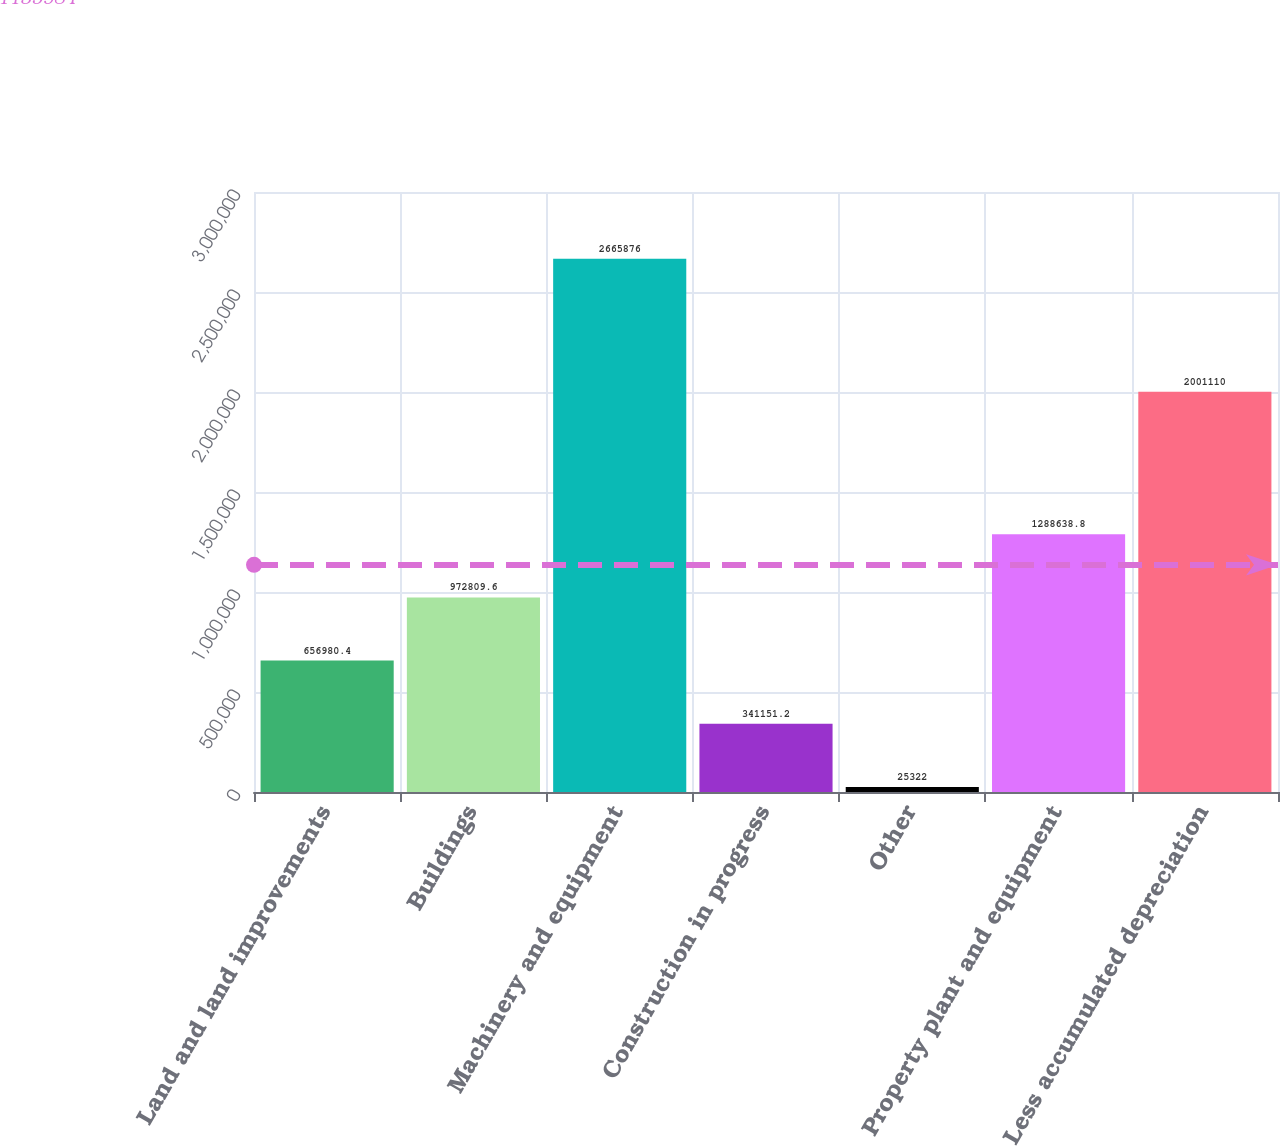<chart> <loc_0><loc_0><loc_500><loc_500><bar_chart><fcel>Land and land improvements<fcel>Buildings<fcel>Machinery and equipment<fcel>Construction in progress<fcel>Other<fcel>Property plant and equipment<fcel>Less accumulated depreciation<nl><fcel>656980<fcel>972810<fcel>2.66588e+06<fcel>341151<fcel>25322<fcel>1.28864e+06<fcel>2.00111e+06<nl></chart> 